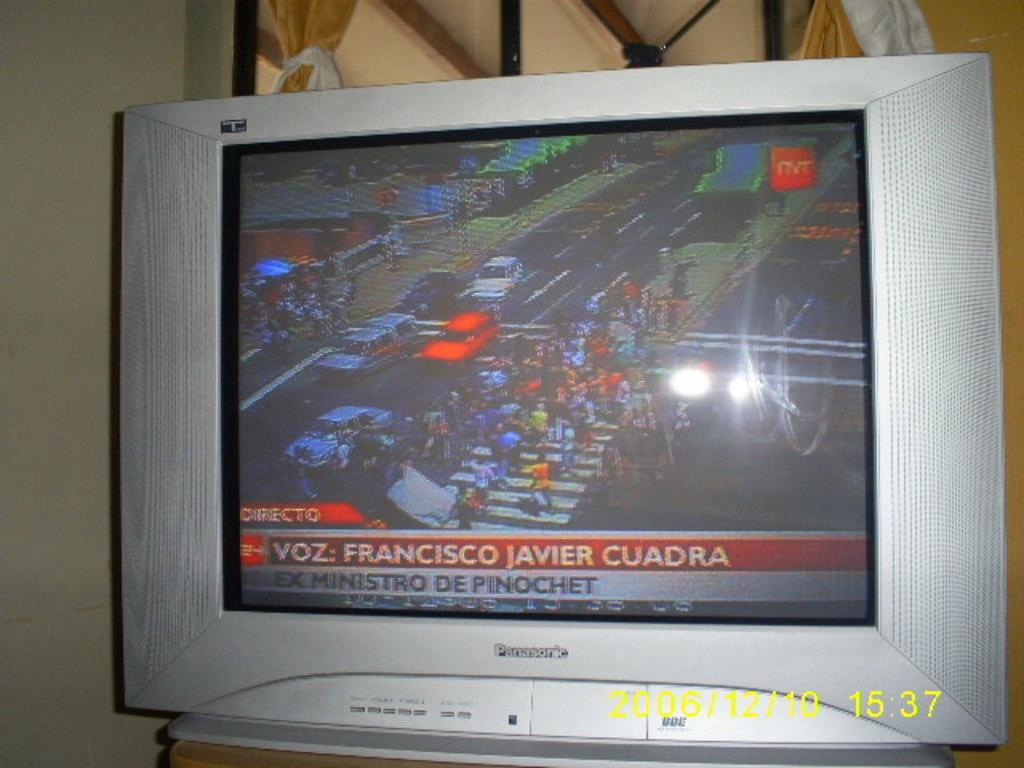<image>
Relay a brief, clear account of the picture shown. An old silver TV says Panasonic on the front and shows a news report of people marching down a street. 